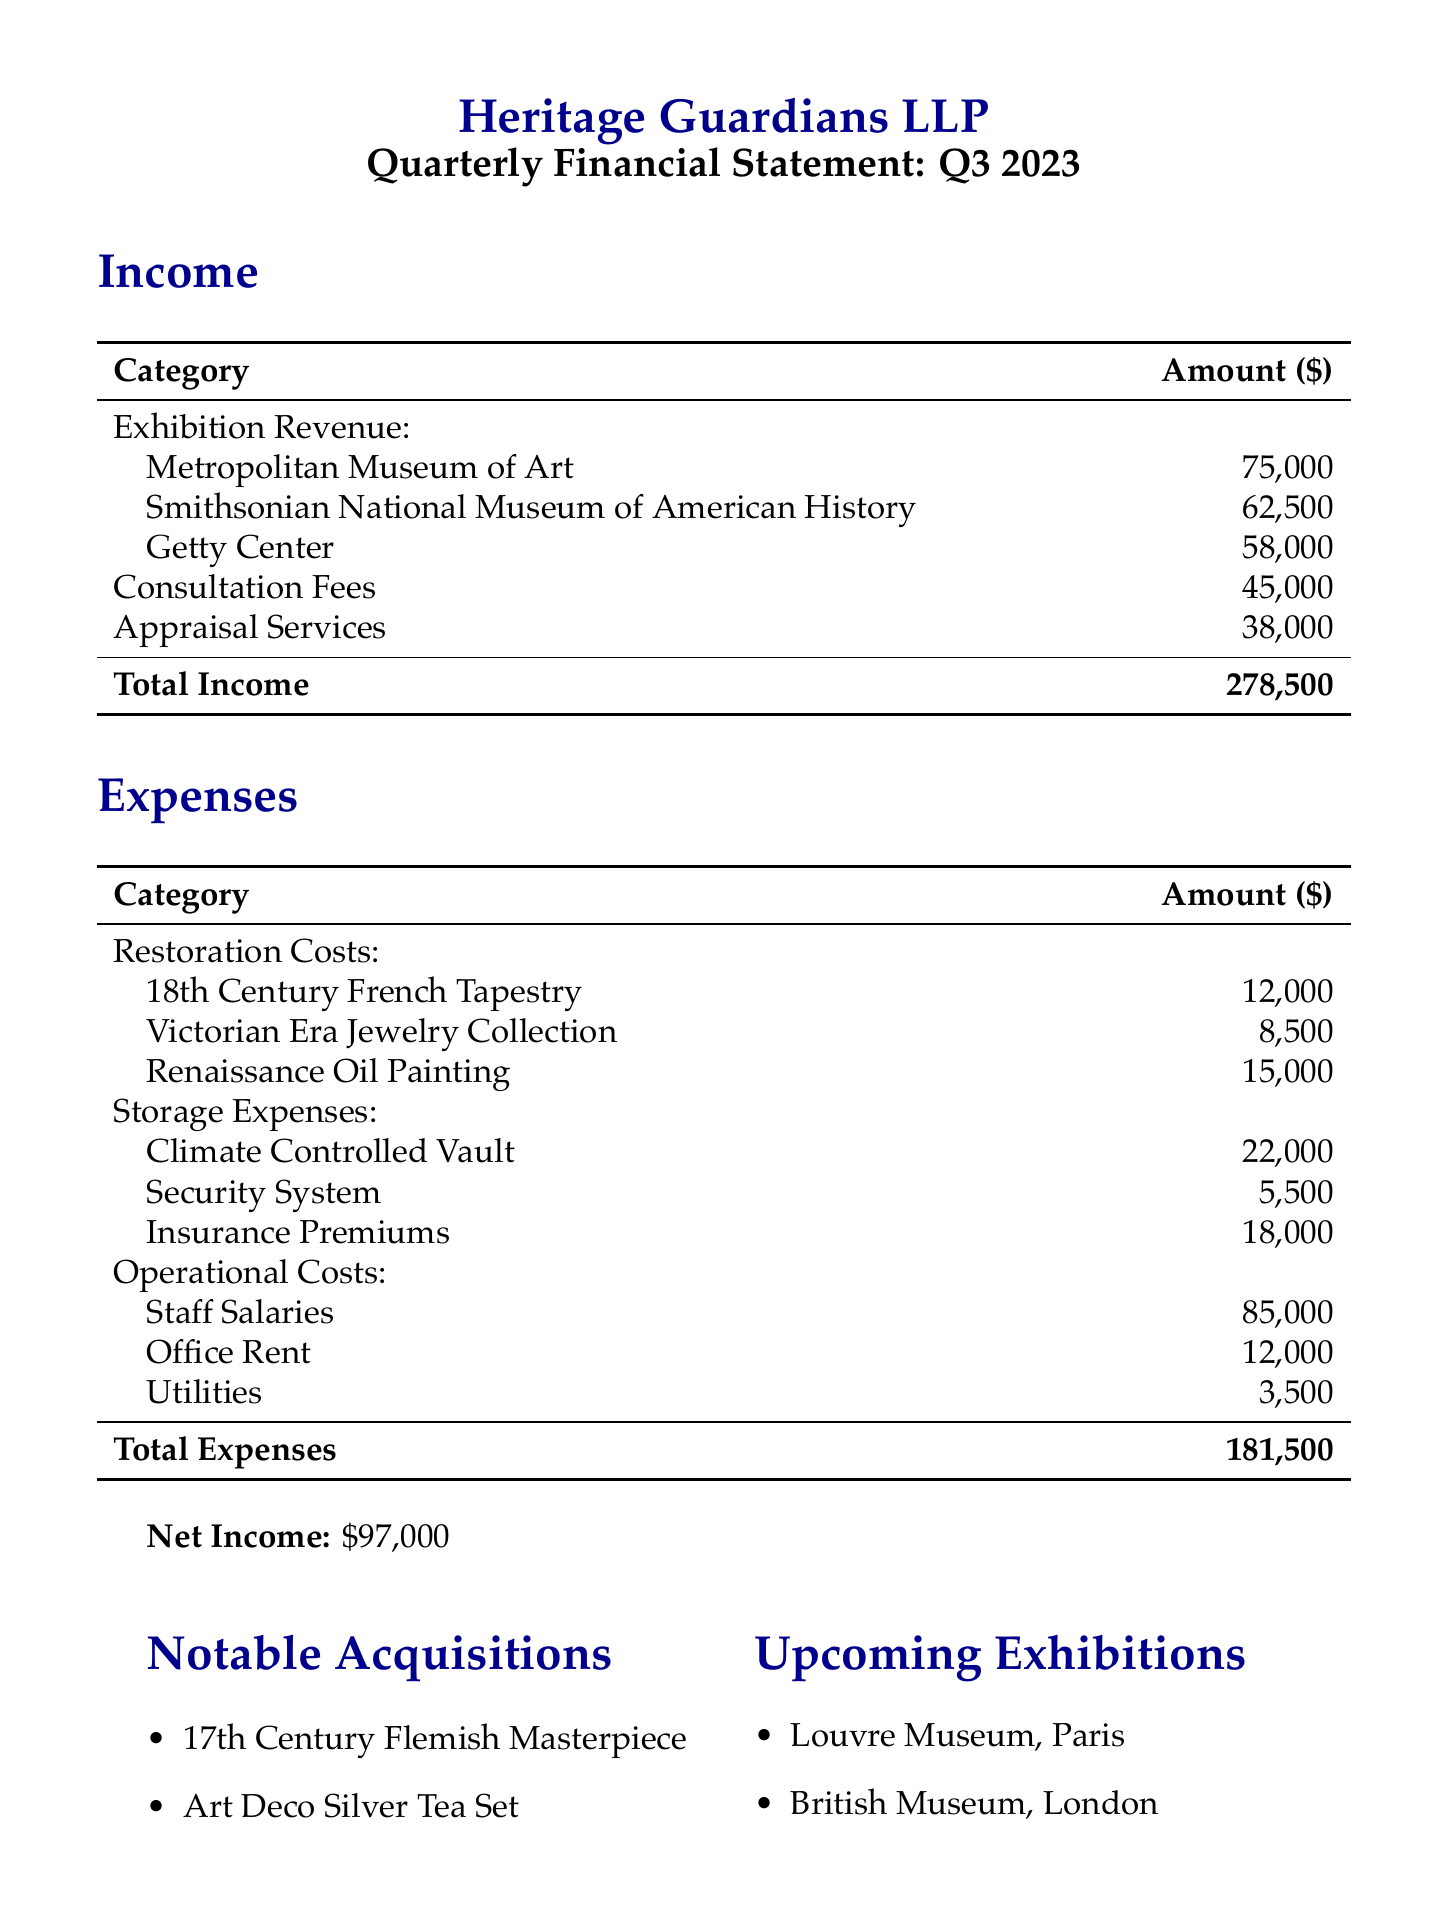What is the total income for Q3 2023? The total income is calculated by summing the exhibition revenue, consultation fees, and appraisal services. The total income is $278,500.
Answer: $278,500 How much was spent on restoration costs for the Renaissance Oil Painting? The amount spent on restoration costs for the Renaissance Oil Painting is explicitly listed in the expenses section. It is $15,000.
Answer: $15,000 What is the net income reported in the statement? The net income is summarized at the end of the financial report, which is $97,000.
Answer: $97,000 Which museum will have an upcoming exhibition in Paris? The document lists upcoming exhibitions, and the Louvre Museum in Paris is mentioned as one of them.
Answer: Louvre Museum What was the cost of the Climate Controlled Vault storage? The cost for the Climate Controlled Vault storage is specified in the storage expenses part of the document. It is $22,000.
Answer: $22,000 Which notable acquisition is associated with the 17th Century? The notable acquisition mentioned is the 17th Century Flemish Masterpiece, explicitly listed in the notable acquisitions section.
Answer: 17th Century Flemish Masterpiece What were the operational costs for Staff Salaries? The operational costs detail the amount spent on staff salaries, which is provided in the expenses section. It is $85,000.
Answer: $85,000 How much income was generated from the Smithsonian National Museum of American History? The income generated from the Smithsonian National Museum of American History is detailed under exhibition revenue, which is $62,500.
Answer: $62,500 